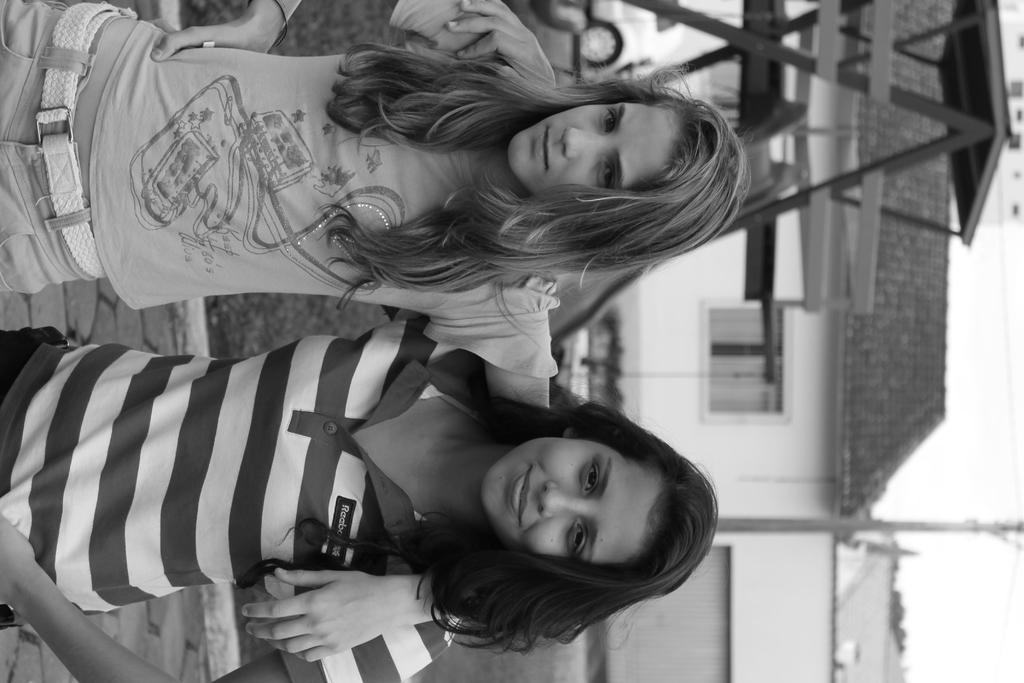What is the color scheme of the image? The image is black and white. Who or what can be seen in the center of the image? There are two girls in the center of the image. What can be seen in the background of the image? There are houses in the background of the image. What object is present in the image besides the girls and houses? There is a pole in the image. Where is the wool field located in the image? There is no wool field present in the image. What type of meeting is taking place between the two girls in the image? There is no meeting taking place between the two girls in the image; they are simply standing together. 